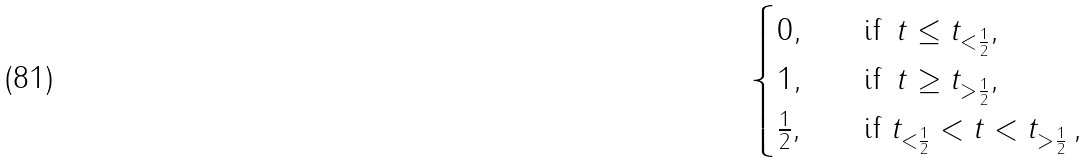<formula> <loc_0><loc_0><loc_500><loc_500>\begin{cases} 0 , \quad & \text {if } \, t \leq t _ { < \frac { 1 } { 2 } } , \\ 1 , \quad & \text {if } \, t \geq t _ { > \frac { 1 } { 2 } } , \\ \frac { 1 } { 2 } , \quad & \text {if } t _ { < \frac { 1 } { 2 } } < t < t _ { > \frac { 1 } { 2 } } \, , \end{cases}</formula> 